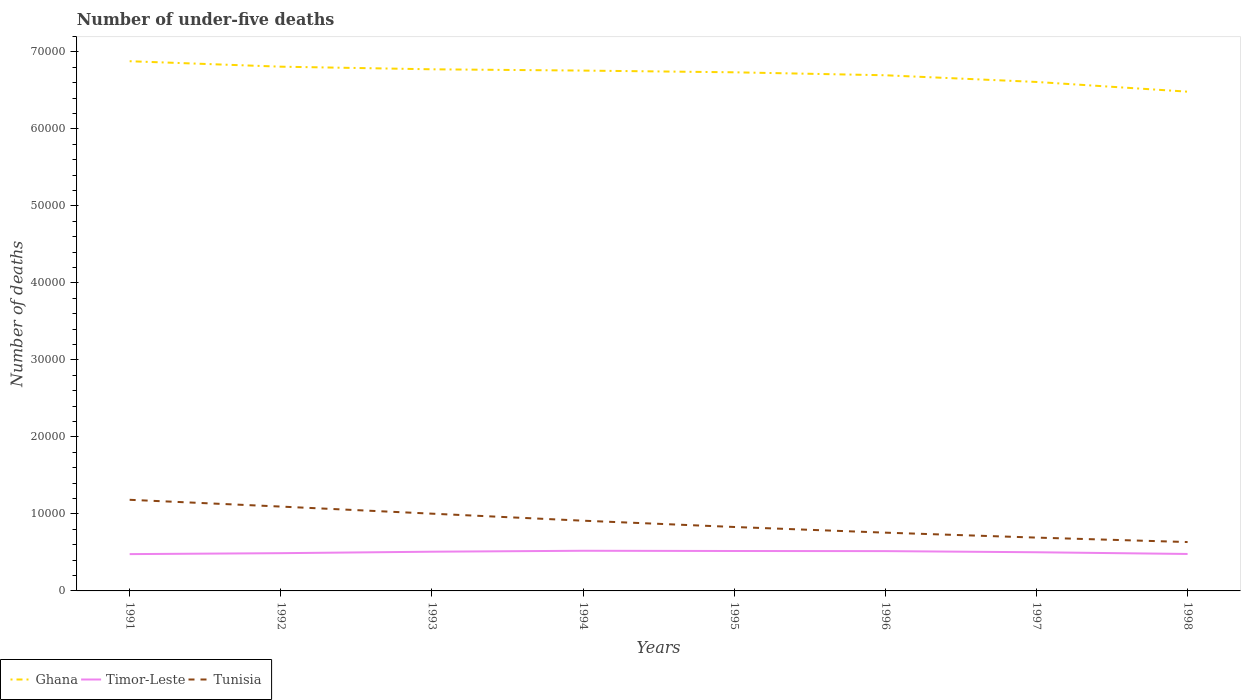How many different coloured lines are there?
Give a very brief answer. 3. Across all years, what is the maximum number of under-five deaths in Timor-Leste?
Your answer should be compact. 4782. What is the total number of under-five deaths in Ghana in the graph?
Give a very brief answer. 1825. What is the difference between the highest and the second highest number of under-five deaths in Ghana?
Your answer should be compact. 3954. What is the difference between the highest and the lowest number of under-five deaths in Ghana?
Offer a very short reply. 5. Is the number of under-five deaths in Ghana strictly greater than the number of under-five deaths in Tunisia over the years?
Your answer should be compact. No. How many lines are there?
Your answer should be very brief. 3. How many years are there in the graph?
Provide a succinct answer. 8. How many legend labels are there?
Your answer should be very brief. 3. How are the legend labels stacked?
Give a very brief answer. Horizontal. What is the title of the graph?
Make the answer very short. Number of under-five deaths. What is the label or title of the X-axis?
Your answer should be compact. Years. What is the label or title of the Y-axis?
Your answer should be very brief. Number of deaths. What is the Number of deaths in Ghana in 1991?
Offer a terse response. 6.88e+04. What is the Number of deaths of Timor-Leste in 1991?
Keep it short and to the point. 4782. What is the Number of deaths of Tunisia in 1991?
Your response must be concise. 1.18e+04. What is the Number of deaths of Ghana in 1992?
Give a very brief answer. 6.81e+04. What is the Number of deaths of Timor-Leste in 1992?
Provide a succinct answer. 4904. What is the Number of deaths of Tunisia in 1992?
Provide a succinct answer. 1.10e+04. What is the Number of deaths of Ghana in 1993?
Keep it short and to the point. 6.78e+04. What is the Number of deaths of Timor-Leste in 1993?
Make the answer very short. 5093. What is the Number of deaths of Tunisia in 1993?
Make the answer very short. 1.00e+04. What is the Number of deaths of Ghana in 1994?
Your answer should be compact. 6.76e+04. What is the Number of deaths of Timor-Leste in 1994?
Keep it short and to the point. 5215. What is the Number of deaths of Tunisia in 1994?
Offer a very short reply. 9122. What is the Number of deaths of Ghana in 1995?
Your answer should be very brief. 6.74e+04. What is the Number of deaths of Timor-Leste in 1995?
Offer a very short reply. 5186. What is the Number of deaths of Tunisia in 1995?
Your answer should be compact. 8305. What is the Number of deaths in Ghana in 1996?
Give a very brief answer. 6.70e+04. What is the Number of deaths of Timor-Leste in 1996?
Keep it short and to the point. 5170. What is the Number of deaths in Tunisia in 1996?
Ensure brevity in your answer.  7568. What is the Number of deaths in Ghana in 1997?
Keep it short and to the point. 6.61e+04. What is the Number of deaths in Timor-Leste in 1997?
Provide a short and direct response. 5023. What is the Number of deaths in Tunisia in 1997?
Offer a terse response. 6926. What is the Number of deaths of Ghana in 1998?
Keep it short and to the point. 6.48e+04. What is the Number of deaths in Timor-Leste in 1998?
Provide a succinct answer. 4799. What is the Number of deaths in Tunisia in 1998?
Ensure brevity in your answer.  6348. Across all years, what is the maximum Number of deaths of Ghana?
Give a very brief answer. 6.88e+04. Across all years, what is the maximum Number of deaths of Timor-Leste?
Your answer should be very brief. 5215. Across all years, what is the maximum Number of deaths in Tunisia?
Your answer should be compact. 1.18e+04. Across all years, what is the minimum Number of deaths of Ghana?
Keep it short and to the point. 6.48e+04. Across all years, what is the minimum Number of deaths in Timor-Leste?
Give a very brief answer. 4782. Across all years, what is the minimum Number of deaths in Tunisia?
Provide a succinct answer. 6348. What is the total Number of deaths of Ghana in the graph?
Offer a terse response. 5.38e+05. What is the total Number of deaths of Timor-Leste in the graph?
Provide a succinct answer. 4.02e+04. What is the total Number of deaths of Tunisia in the graph?
Your response must be concise. 7.11e+04. What is the difference between the Number of deaths in Ghana in 1991 and that in 1992?
Ensure brevity in your answer.  709. What is the difference between the Number of deaths in Timor-Leste in 1991 and that in 1992?
Ensure brevity in your answer.  -122. What is the difference between the Number of deaths in Tunisia in 1991 and that in 1992?
Your answer should be compact. 880. What is the difference between the Number of deaths in Ghana in 1991 and that in 1993?
Provide a succinct answer. 1049. What is the difference between the Number of deaths of Timor-Leste in 1991 and that in 1993?
Provide a short and direct response. -311. What is the difference between the Number of deaths of Tunisia in 1991 and that in 1993?
Provide a succinct answer. 1802. What is the difference between the Number of deaths in Ghana in 1991 and that in 1994?
Give a very brief answer. 1216. What is the difference between the Number of deaths in Timor-Leste in 1991 and that in 1994?
Your answer should be very brief. -433. What is the difference between the Number of deaths in Tunisia in 1991 and that in 1994?
Offer a very short reply. 2714. What is the difference between the Number of deaths in Ghana in 1991 and that in 1995?
Offer a terse response. 1439. What is the difference between the Number of deaths of Timor-Leste in 1991 and that in 1995?
Keep it short and to the point. -404. What is the difference between the Number of deaths in Tunisia in 1991 and that in 1995?
Provide a short and direct response. 3531. What is the difference between the Number of deaths in Ghana in 1991 and that in 1996?
Offer a very short reply. 1825. What is the difference between the Number of deaths of Timor-Leste in 1991 and that in 1996?
Offer a terse response. -388. What is the difference between the Number of deaths of Tunisia in 1991 and that in 1996?
Ensure brevity in your answer.  4268. What is the difference between the Number of deaths in Ghana in 1991 and that in 1997?
Your answer should be very brief. 2693. What is the difference between the Number of deaths of Timor-Leste in 1991 and that in 1997?
Your answer should be very brief. -241. What is the difference between the Number of deaths of Tunisia in 1991 and that in 1997?
Your response must be concise. 4910. What is the difference between the Number of deaths in Ghana in 1991 and that in 1998?
Keep it short and to the point. 3954. What is the difference between the Number of deaths in Tunisia in 1991 and that in 1998?
Provide a short and direct response. 5488. What is the difference between the Number of deaths of Ghana in 1992 and that in 1993?
Your answer should be very brief. 340. What is the difference between the Number of deaths in Timor-Leste in 1992 and that in 1993?
Your response must be concise. -189. What is the difference between the Number of deaths in Tunisia in 1992 and that in 1993?
Your answer should be compact. 922. What is the difference between the Number of deaths in Ghana in 1992 and that in 1994?
Keep it short and to the point. 507. What is the difference between the Number of deaths of Timor-Leste in 1992 and that in 1994?
Provide a short and direct response. -311. What is the difference between the Number of deaths in Tunisia in 1992 and that in 1994?
Provide a short and direct response. 1834. What is the difference between the Number of deaths of Ghana in 1992 and that in 1995?
Offer a terse response. 730. What is the difference between the Number of deaths of Timor-Leste in 1992 and that in 1995?
Provide a succinct answer. -282. What is the difference between the Number of deaths in Tunisia in 1992 and that in 1995?
Offer a terse response. 2651. What is the difference between the Number of deaths of Ghana in 1992 and that in 1996?
Your answer should be very brief. 1116. What is the difference between the Number of deaths of Timor-Leste in 1992 and that in 1996?
Your response must be concise. -266. What is the difference between the Number of deaths in Tunisia in 1992 and that in 1996?
Your response must be concise. 3388. What is the difference between the Number of deaths of Ghana in 1992 and that in 1997?
Your answer should be very brief. 1984. What is the difference between the Number of deaths of Timor-Leste in 1992 and that in 1997?
Provide a succinct answer. -119. What is the difference between the Number of deaths of Tunisia in 1992 and that in 1997?
Provide a succinct answer. 4030. What is the difference between the Number of deaths in Ghana in 1992 and that in 1998?
Your answer should be very brief. 3245. What is the difference between the Number of deaths of Timor-Leste in 1992 and that in 1998?
Offer a very short reply. 105. What is the difference between the Number of deaths of Tunisia in 1992 and that in 1998?
Your response must be concise. 4608. What is the difference between the Number of deaths of Ghana in 1993 and that in 1994?
Provide a succinct answer. 167. What is the difference between the Number of deaths of Timor-Leste in 1993 and that in 1994?
Your response must be concise. -122. What is the difference between the Number of deaths in Tunisia in 1993 and that in 1994?
Your answer should be very brief. 912. What is the difference between the Number of deaths in Ghana in 1993 and that in 1995?
Your response must be concise. 390. What is the difference between the Number of deaths of Timor-Leste in 1993 and that in 1995?
Keep it short and to the point. -93. What is the difference between the Number of deaths of Tunisia in 1993 and that in 1995?
Give a very brief answer. 1729. What is the difference between the Number of deaths of Ghana in 1993 and that in 1996?
Ensure brevity in your answer.  776. What is the difference between the Number of deaths of Timor-Leste in 1993 and that in 1996?
Keep it short and to the point. -77. What is the difference between the Number of deaths in Tunisia in 1993 and that in 1996?
Make the answer very short. 2466. What is the difference between the Number of deaths in Ghana in 1993 and that in 1997?
Provide a succinct answer. 1644. What is the difference between the Number of deaths of Timor-Leste in 1993 and that in 1997?
Provide a short and direct response. 70. What is the difference between the Number of deaths of Tunisia in 1993 and that in 1997?
Provide a short and direct response. 3108. What is the difference between the Number of deaths in Ghana in 1993 and that in 1998?
Your response must be concise. 2905. What is the difference between the Number of deaths in Timor-Leste in 1993 and that in 1998?
Offer a terse response. 294. What is the difference between the Number of deaths in Tunisia in 1993 and that in 1998?
Provide a succinct answer. 3686. What is the difference between the Number of deaths of Ghana in 1994 and that in 1995?
Your answer should be very brief. 223. What is the difference between the Number of deaths in Timor-Leste in 1994 and that in 1995?
Provide a short and direct response. 29. What is the difference between the Number of deaths in Tunisia in 1994 and that in 1995?
Your answer should be compact. 817. What is the difference between the Number of deaths in Ghana in 1994 and that in 1996?
Offer a terse response. 609. What is the difference between the Number of deaths of Timor-Leste in 1994 and that in 1996?
Ensure brevity in your answer.  45. What is the difference between the Number of deaths in Tunisia in 1994 and that in 1996?
Make the answer very short. 1554. What is the difference between the Number of deaths of Ghana in 1994 and that in 1997?
Your response must be concise. 1477. What is the difference between the Number of deaths of Timor-Leste in 1994 and that in 1997?
Your answer should be compact. 192. What is the difference between the Number of deaths in Tunisia in 1994 and that in 1997?
Ensure brevity in your answer.  2196. What is the difference between the Number of deaths of Ghana in 1994 and that in 1998?
Make the answer very short. 2738. What is the difference between the Number of deaths in Timor-Leste in 1994 and that in 1998?
Offer a terse response. 416. What is the difference between the Number of deaths in Tunisia in 1994 and that in 1998?
Your answer should be compact. 2774. What is the difference between the Number of deaths in Ghana in 1995 and that in 1996?
Provide a succinct answer. 386. What is the difference between the Number of deaths in Tunisia in 1995 and that in 1996?
Provide a succinct answer. 737. What is the difference between the Number of deaths of Ghana in 1995 and that in 1997?
Keep it short and to the point. 1254. What is the difference between the Number of deaths of Timor-Leste in 1995 and that in 1997?
Your answer should be compact. 163. What is the difference between the Number of deaths of Tunisia in 1995 and that in 1997?
Provide a short and direct response. 1379. What is the difference between the Number of deaths of Ghana in 1995 and that in 1998?
Make the answer very short. 2515. What is the difference between the Number of deaths of Timor-Leste in 1995 and that in 1998?
Ensure brevity in your answer.  387. What is the difference between the Number of deaths of Tunisia in 1995 and that in 1998?
Your response must be concise. 1957. What is the difference between the Number of deaths in Ghana in 1996 and that in 1997?
Keep it short and to the point. 868. What is the difference between the Number of deaths of Timor-Leste in 1996 and that in 1997?
Your response must be concise. 147. What is the difference between the Number of deaths in Tunisia in 1996 and that in 1997?
Offer a terse response. 642. What is the difference between the Number of deaths of Ghana in 1996 and that in 1998?
Offer a very short reply. 2129. What is the difference between the Number of deaths of Timor-Leste in 1996 and that in 1998?
Your answer should be compact. 371. What is the difference between the Number of deaths of Tunisia in 1996 and that in 1998?
Offer a very short reply. 1220. What is the difference between the Number of deaths in Ghana in 1997 and that in 1998?
Your answer should be compact. 1261. What is the difference between the Number of deaths in Timor-Leste in 1997 and that in 1998?
Your answer should be very brief. 224. What is the difference between the Number of deaths of Tunisia in 1997 and that in 1998?
Make the answer very short. 578. What is the difference between the Number of deaths in Ghana in 1991 and the Number of deaths in Timor-Leste in 1992?
Offer a very short reply. 6.39e+04. What is the difference between the Number of deaths in Ghana in 1991 and the Number of deaths in Tunisia in 1992?
Your response must be concise. 5.78e+04. What is the difference between the Number of deaths of Timor-Leste in 1991 and the Number of deaths of Tunisia in 1992?
Provide a short and direct response. -6174. What is the difference between the Number of deaths of Ghana in 1991 and the Number of deaths of Timor-Leste in 1993?
Keep it short and to the point. 6.37e+04. What is the difference between the Number of deaths of Ghana in 1991 and the Number of deaths of Tunisia in 1993?
Keep it short and to the point. 5.88e+04. What is the difference between the Number of deaths of Timor-Leste in 1991 and the Number of deaths of Tunisia in 1993?
Your answer should be compact. -5252. What is the difference between the Number of deaths in Ghana in 1991 and the Number of deaths in Timor-Leste in 1994?
Make the answer very short. 6.36e+04. What is the difference between the Number of deaths of Ghana in 1991 and the Number of deaths of Tunisia in 1994?
Offer a terse response. 5.97e+04. What is the difference between the Number of deaths of Timor-Leste in 1991 and the Number of deaths of Tunisia in 1994?
Give a very brief answer. -4340. What is the difference between the Number of deaths of Ghana in 1991 and the Number of deaths of Timor-Leste in 1995?
Offer a very short reply. 6.36e+04. What is the difference between the Number of deaths of Ghana in 1991 and the Number of deaths of Tunisia in 1995?
Your answer should be compact. 6.05e+04. What is the difference between the Number of deaths in Timor-Leste in 1991 and the Number of deaths in Tunisia in 1995?
Make the answer very short. -3523. What is the difference between the Number of deaths in Ghana in 1991 and the Number of deaths in Timor-Leste in 1996?
Keep it short and to the point. 6.36e+04. What is the difference between the Number of deaths in Ghana in 1991 and the Number of deaths in Tunisia in 1996?
Make the answer very short. 6.12e+04. What is the difference between the Number of deaths of Timor-Leste in 1991 and the Number of deaths of Tunisia in 1996?
Provide a succinct answer. -2786. What is the difference between the Number of deaths in Ghana in 1991 and the Number of deaths in Timor-Leste in 1997?
Offer a terse response. 6.38e+04. What is the difference between the Number of deaths of Ghana in 1991 and the Number of deaths of Tunisia in 1997?
Keep it short and to the point. 6.19e+04. What is the difference between the Number of deaths of Timor-Leste in 1991 and the Number of deaths of Tunisia in 1997?
Make the answer very short. -2144. What is the difference between the Number of deaths in Ghana in 1991 and the Number of deaths in Timor-Leste in 1998?
Your answer should be compact. 6.40e+04. What is the difference between the Number of deaths of Ghana in 1991 and the Number of deaths of Tunisia in 1998?
Your answer should be compact. 6.25e+04. What is the difference between the Number of deaths in Timor-Leste in 1991 and the Number of deaths in Tunisia in 1998?
Offer a terse response. -1566. What is the difference between the Number of deaths in Ghana in 1992 and the Number of deaths in Timor-Leste in 1993?
Provide a succinct answer. 6.30e+04. What is the difference between the Number of deaths of Ghana in 1992 and the Number of deaths of Tunisia in 1993?
Provide a short and direct response. 5.81e+04. What is the difference between the Number of deaths of Timor-Leste in 1992 and the Number of deaths of Tunisia in 1993?
Your response must be concise. -5130. What is the difference between the Number of deaths of Ghana in 1992 and the Number of deaths of Timor-Leste in 1994?
Offer a very short reply. 6.29e+04. What is the difference between the Number of deaths of Ghana in 1992 and the Number of deaths of Tunisia in 1994?
Your answer should be compact. 5.90e+04. What is the difference between the Number of deaths of Timor-Leste in 1992 and the Number of deaths of Tunisia in 1994?
Offer a terse response. -4218. What is the difference between the Number of deaths in Ghana in 1992 and the Number of deaths in Timor-Leste in 1995?
Keep it short and to the point. 6.29e+04. What is the difference between the Number of deaths in Ghana in 1992 and the Number of deaths in Tunisia in 1995?
Offer a terse response. 5.98e+04. What is the difference between the Number of deaths in Timor-Leste in 1992 and the Number of deaths in Tunisia in 1995?
Your answer should be compact. -3401. What is the difference between the Number of deaths of Ghana in 1992 and the Number of deaths of Timor-Leste in 1996?
Your answer should be compact. 6.29e+04. What is the difference between the Number of deaths in Ghana in 1992 and the Number of deaths in Tunisia in 1996?
Ensure brevity in your answer.  6.05e+04. What is the difference between the Number of deaths of Timor-Leste in 1992 and the Number of deaths of Tunisia in 1996?
Your answer should be compact. -2664. What is the difference between the Number of deaths in Ghana in 1992 and the Number of deaths in Timor-Leste in 1997?
Give a very brief answer. 6.31e+04. What is the difference between the Number of deaths of Ghana in 1992 and the Number of deaths of Tunisia in 1997?
Offer a terse response. 6.12e+04. What is the difference between the Number of deaths of Timor-Leste in 1992 and the Number of deaths of Tunisia in 1997?
Provide a short and direct response. -2022. What is the difference between the Number of deaths of Ghana in 1992 and the Number of deaths of Timor-Leste in 1998?
Provide a short and direct response. 6.33e+04. What is the difference between the Number of deaths in Ghana in 1992 and the Number of deaths in Tunisia in 1998?
Your response must be concise. 6.17e+04. What is the difference between the Number of deaths in Timor-Leste in 1992 and the Number of deaths in Tunisia in 1998?
Keep it short and to the point. -1444. What is the difference between the Number of deaths in Ghana in 1993 and the Number of deaths in Timor-Leste in 1994?
Provide a short and direct response. 6.25e+04. What is the difference between the Number of deaths in Ghana in 1993 and the Number of deaths in Tunisia in 1994?
Offer a terse response. 5.86e+04. What is the difference between the Number of deaths of Timor-Leste in 1993 and the Number of deaths of Tunisia in 1994?
Your answer should be compact. -4029. What is the difference between the Number of deaths of Ghana in 1993 and the Number of deaths of Timor-Leste in 1995?
Your answer should be very brief. 6.26e+04. What is the difference between the Number of deaths of Ghana in 1993 and the Number of deaths of Tunisia in 1995?
Your answer should be very brief. 5.94e+04. What is the difference between the Number of deaths in Timor-Leste in 1993 and the Number of deaths in Tunisia in 1995?
Provide a succinct answer. -3212. What is the difference between the Number of deaths in Ghana in 1993 and the Number of deaths in Timor-Leste in 1996?
Provide a short and direct response. 6.26e+04. What is the difference between the Number of deaths of Ghana in 1993 and the Number of deaths of Tunisia in 1996?
Offer a terse response. 6.02e+04. What is the difference between the Number of deaths in Timor-Leste in 1993 and the Number of deaths in Tunisia in 1996?
Offer a terse response. -2475. What is the difference between the Number of deaths of Ghana in 1993 and the Number of deaths of Timor-Leste in 1997?
Your response must be concise. 6.27e+04. What is the difference between the Number of deaths in Ghana in 1993 and the Number of deaths in Tunisia in 1997?
Your answer should be very brief. 6.08e+04. What is the difference between the Number of deaths in Timor-Leste in 1993 and the Number of deaths in Tunisia in 1997?
Ensure brevity in your answer.  -1833. What is the difference between the Number of deaths of Ghana in 1993 and the Number of deaths of Timor-Leste in 1998?
Offer a very short reply. 6.30e+04. What is the difference between the Number of deaths of Ghana in 1993 and the Number of deaths of Tunisia in 1998?
Your response must be concise. 6.14e+04. What is the difference between the Number of deaths in Timor-Leste in 1993 and the Number of deaths in Tunisia in 1998?
Provide a succinct answer. -1255. What is the difference between the Number of deaths of Ghana in 1994 and the Number of deaths of Timor-Leste in 1995?
Give a very brief answer. 6.24e+04. What is the difference between the Number of deaths in Ghana in 1994 and the Number of deaths in Tunisia in 1995?
Provide a short and direct response. 5.93e+04. What is the difference between the Number of deaths of Timor-Leste in 1994 and the Number of deaths of Tunisia in 1995?
Offer a very short reply. -3090. What is the difference between the Number of deaths in Ghana in 1994 and the Number of deaths in Timor-Leste in 1996?
Offer a very short reply. 6.24e+04. What is the difference between the Number of deaths in Ghana in 1994 and the Number of deaths in Tunisia in 1996?
Make the answer very short. 6.00e+04. What is the difference between the Number of deaths in Timor-Leste in 1994 and the Number of deaths in Tunisia in 1996?
Your response must be concise. -2353. What is the difference between the Number of deaths in Ghana in 1994 and the Number of deaths in Timor-Leste in 1997?
Give a very brief answer. 6.26e+04. What is the difference between the Number of deaths of Ghana in 1994 and the Number of deaths of Tunisia in 1997?
Offer a terse response. 6.07e+04. What is the difference between the Number of deaths of Timor-Leste in 1994 and the Number of deaths of Tunisia in 1997?
Provide a short and direct response. -1711. What is the difference between the Number of deaths of Ghana in 1994 and the Number of deaths of Timor-Leste in 1998?
Provide a succinct answer. 6.28e+04. What is the difference between the Number of deaths in Ghana in 1994 and the Number of deaths in Tunisia in 1998?
Provide a succinct answer. 6.12e+04. What is the difference between the Number of deaths in Timor-Leste in 1994 and the Number of deaths in Tunisia in 1998?
Provide a short and direct response. -1133. What is the difference between the Number of deaths in Ghana in 1995 and the Number of deaths in Timor-Leste in 1996?
Give a very brief answer. 6.22e+04. What is the difference between the Number of deaths of Ghana in 1995 and the Number of deaths of Tunisia in 1996?
Keep it short and to the point. 5.98e+04. What is the difference between the Number of deaths of Timor-Leste in 1995 and the Number of deaths of Tunisia in 1996?
Offer a terse response. -2382. What is the difference between the Number of deaths in Ghana in 1995 and the Number of deaths in Timor-Leste in 1997?
Offer a terse response. 6.23e+04. What is the difference between the Number of deaths in Ghana in 1995 and the Number of deaths in Tunisia in 1997?
Keep it short and to the point. 6.04e+04. What is the difference between the Number of deaths of Timor-Leste in 1995 and the Number of deaths of Tunisia in 1997?
Offer a terse response. -1740. What is the difference between the Number of deaths in Ghana in 1995 and the Number of deaths in Timor-Leste in 1998?
Make the answer very short. 6.26e+04. What is the difference between the Number of deaths of Ghana in 1995 and the Number of deaths of Tunisia in 1998?
Give a very brief answer. 6.10e+04. What is the difference between the Number of deaths in Timor-Leste in 1995 and the Number of deaths in Tunisia in 1998?
Provide a succinct answer. -1162. What is the difference between the Number of deaths in Ghana in 1996 and the Number of deaths in Timor-Leste in 1997?
Offer a very short reply. 6.20e+04. What is the difference between the Number of deaths in Ghana in 1996 and the Number of deaths in Tunisia in 1997?
Give a very brief answer. 6.00e+04. What is the difference between the Number of deaths in Timor-Leste in 1996 and the Number of deaths in Tunisia in 1997?
Ensure brevity in your answer.  -1756. What is the difference between the Number of deaths of Ghana in 1996 and the Number of deaths of Timor-Leste in 1998?
Ensure brevity in your answer.  6.22e+04. What is the difference between the Number of deaths of Ghana in 1996 and the Number of deaths of Tunisia in 1998?
Keep it short and to the point. 6.06e+04. What is the difference between the Number of deaths in Timor-Leste in 1996 and the Number of deaths in Tunisia in 1998?
Provide a succinct answer. -1178. What is the difference between the Number of deaths in Ghana in 1997 and the Number of deaths in Timor-Leste in 1998?
Your answer should be very brief. 6.13e+04. What is the difference between the Number of deaths of Ghana in 1997 and the Number of deaths of Tunisia in 1998?
Ensure brevity in your answer.  5.98e+04. What is the difference between the Number of deaths in Timor-Leste in 1997 and the Number of deaths in Tunisia in 1998?
Ensure brevity in your answer.  -1325. What is the average Number of deaths in Ghana per year?
Provide a succinct answer. 6.72e+04. What is the average Number of deaths of Timor-Leste per year?
Your answer should be compact. 5021.5. What is the average Number of deaths in Tunisia per year?
Your response must be concise. 8886.88. In the year 1991, what is the difference between the Number of deaths in Ghana and Number of deaths in Timor-Leste?
Offer a very short reply. 6.40e+04. In the year 1991, what is the difference between the Number of deaths in Ghana and Number of deaths in Tunisia?
Your response must be concise. 5.70e+04. In the year 1991, what is the difference between the Number of deaths in Timor-Leste and Number of deaths in Tunisia?
Offer a terse response. -7054. In the year 1992, what is the difference between the Number of deaths in Ghana and Number of deaths in Timor-Leste?
Offer a very short reply. 6.32e+04. In the year 1992, what is the difference between the Number of deaths of Ghana and Number of deaths of Tunisia?
Keep it short and to the point. 5.71e+04. In the year 1992, what is the difference between the Number of deaths of Timor-Leste and Number of deaths of Tunisia?
Provide a succinct answer. -6052. In the year 1993, what is the difference between the Number of deaths of Ghana and Number of deaths of Timor-Leste?
Make the answer very short. 6.27e+04. In the year 1993, what is the difference between the Number of deaths in Ghana and Number of deaths in Tunisia?
Keep it short and to the point. 5.77e+04. In the year 1993, what is the difference between the Number of deaths in Timor-Leste and Number of deaths in Tunisia?
Provide a succinct answer. -4941. In the year 1994, what is the difference between the Number of deaths of Ghana and Number of deaths of Timor-Leste?
Give a very brief answer. 6.24e+04. In the year 1994, what is the difference between the Number of deaths of Ghana and Number of deaths of Tunisia?
Give a very brief answer. 5.85e+04. In the year 1994, what is the difference between the Number of deaths in Timor-Leste and Number of deaths in Tunisia?
Ensure brevity in your answer.  -3907. In the year 1995, what is the difference between the Number of deaths in Ghana and Number of deaths in Timor-Leste?
Give a very brief answer. 6.22e+04. In the year 1995, what is the difference between the Number of deaths of Ghana and Number of deaths of Tunisia?
Your answer should be compact. 5.91e+04. In the year 1995, what is the difference between the Number of deaths in Timor-Leste and Number of deaths in Tunisia?
Your answer should be compact. -3119. In the year 1996, what is the difference between the Number of deaths in Ghana and Number of deaths in Timor-Leste?
Give a very brief answer. 6.18e+04. In the year 1996, what is the difference between the Number of deaths in Ghana and Number of deaths in Tunisia?
Give a very brief answer. 5.94e+04. In the year 1996, what is the difference between the Number of deaths in Timor-Leste and Number of deaths in Tunisia?
Keep it short and to the point. -2398. In the year 1997, what is the difference between the Number of deaths of Ghana and Number of deaths of Timor-Leste?
Ensure brevity in your answer.  6.11e+04. In the year 1997, what is the difference between the Number of deaths in Ghana and Number of deaths in Tunisia?
Ensure brevity in your answer.  5.92e+04. In the year 1997, what is the difference between the Number of deaths in Timor-Leste and Number of deaths in Tunisia?
Make the answer very short. -1903. In the year 1998, what is the difference between the Number of deaths of Ghana and Number of deaths of Timor-Leste?
Your answer should be compact. 6.00e+04. In the year 1998, what is the difference between the Number of deaths in Ghana and Number of deaths in Tunisia?
Offer a terse response. 5.85e+04. In the year 1998, what is the difference between the Number of deaths in Timor-Leste and Number of deaths in Tunisia?
Offer a terse response. -1549. What is the ratio of the Number of deaths in Ghana in 1991 to that in 1992?
Provide a short and direct response. 1.01. What is the ratio of the Number of deaths of Timor-Leste in 1991 to that in 1992?
Ensure brevity in your answer.  0.98. What is the ratio of the Number of deaths of Tunisia in 1991 to that in 1992?
Give a very brief answer. 1.08. What is the ratio of the Number of deaths in Ghana in 1991 to that in 1993?
Provide a succinct answer. 1.02. What is the ratio of the Number of deaths of Timor-Leste in 1991 to that in 1993?
Ensure brevity in your answer.  0.94. What is the ratio of the Number of deaths of Tunisia in 1991 to that in 1993?
Your answer should be compact. 1.18. What is the ratio of the Number of deaths of Ghana in 1991 to that in 1994?
Ensure brevity in your answer.  1.02. What is the ratio of the Number of deaths of Timor-Leste in 1991 to that in 1994?
Make the answer very short. 0.92. What is the ratio of the Number of deaths in Tunisia in 1991 to that in 1994?
Your response must be concise. 1.3. What is the ratio of the Number of deaths in Ghana in 1991 to that in 1995?
Provide a succinct answer. 1.02. What is the ratio of the Number of deaths of Timor-Leste in 1991 to that in 1995?
Make the answer very short. 0.92. What is the ratio of the Number of deaths of Tunisia in 1991 to that in 1995?
Provide a succinct answer. 1.43. What is the ratio of the Number of deaths in Ghana in 1991 to that in 1996?
Offer a terse response. 1.03. What is the ratio of the Number of deaths in Timor-Leste in 1991 to that in 1996?
Ensure brevity in your answer.  0.93. What is the ratio of the Number of deaths of Tunisia in 1991 to that in 1996?
Keep it short and to the point. 1.56. What is the ratio of the Number of deaths in Ghana in 1991 to that in 1997?
Give a very brief answer. 1.04. What is the ratio of the Number of deaths in Timor-Leste in 1991 to that in 1997?
Provide a succinct answer. 0.95. What is the ratio of the Number of deaths of Tunisia in 1991 to that in 1997?
Give a very brief answer. 1.71. What is the ratio of the Number of deaths of Ghana in 1991 to that in 1998?
Give a very brief answer. 1.06. What is the ratio of the Number of deaths of Timor-Leste in 1991 to that in 1998?
Ensure brevity in your answer.  1. What is the ratio of the Number of deaths of Tunisia in 1991 to that in 1998?
Keep it short and to the point. 1.86. What is the ratio of the Number of deaths of Ghana in 1992 to that in 1993?
Offer a very short reply. 1. What is the ratio of the Number of deaths of Timor-Leste in 1992 to that in 1993?
Your answer should be very brief. 0.96. What is the ratio of the Number of deaths of Tunisia in 1992 to that in 1993?
Ensure brevity in your answer.  1.09. What is the ratio of the Number of deaths of Ghana in 1992 to that in 1994?
Your response must be concise. 1.01. What is the ratio of the Number of deaths of Timor-Leste in 1992 to that in 1994?
Ensure brevity in your answer.  0.94. What is the ratio of the Number of deaths of Tunisia in 1992 to that in 1994?
Your answer should be very brief. 1.2. What is the ratio of the Number of deaths of Ghana in 1992 to that in 1995?
Ensure brevity in your answer.  1.01. What is the ratio of the Number of deaths in Timor-Leste in 1992 to that in 1995?
Ensure brevity in your answer.  0.95. What is the ratio of the Number of deaths of Tunisia in 1992 to that in 1995?
Your answer should be very brief. 1.32. What is the ratio of the Number of deaths of Ghana in 1992 to that in 1996?
Offer a very short reply. 1.02. What is the ratio of the Number of deaths in Timor-Leste in 1992 to that in 1996?
Offer a terse response. 0.95. What is the ratio of the Number of deaths in Tunisia in 1992 to that in 1996?
Keep it short and to the point. 1.45. What is the ratio of the Number of deaths in Ghana in 1992 to that in 1997?
Give a very brief answer. 1.03. What is the ratio of the Number of deaths in Timor-Leste in 1992 to that in 1997?
Your answer should be very brief. 0.98. What is the ratio of the Number of deaths of Tunisia in 1992 to that in 1997?
Your answer should be very brief. 1.58. What is the ratio of the Number of deaths of Timor-Leste in 1992 to that in 1998?
Make the answer very short. 1.02. What is the ratio of the Number of deaths of Tunisia in 1992 to that in 1998?
Keep it short and to the point. 1.73. What is the ratio of the Number of deaths of Timor-Leste in 1993 to that in 1994?
Offer a terse response. 0.98. What is the ratio of the Number of deaths of Tunisia in 1993 to that in 1994?
Your response must be concise. 1.1. What is the ratio of the Number of deaths of Timor-Leste in 1993 to that in 1995?
Provide a succinct answer. 0.98. What is the ratio of the Number of deaths of Tunisia in 1993 to that in 1995?
Ensure brevity in your answer.  1.21. What is the ratio of the Number of deaths of Ghana in 1993 to that in 1996?
Ensure brevity in your answer.  1.01. What is the ratio of the Number of deaths of Timor-Leste in 1993 to that in 1996?
Keep it short and to the point. 0.99. What is the ratio of the Number of deaths of Tunisia in 1993 to that in 1996?
Keep it short and to the point. 1.33. What is the ratio of the Number of deaths in Ghana in 1993 to that in 1997?
Make the answer very short. 1.02. What is the ratio of the Number of deaths in Timor-Leste in 1993 to that in 1997?
Give a very brief answer. 1.01. What is the ratio of the Number of deaths in Tunisia in 1993 to that in 1997?
Ensure brevity in your answer.  1.45. What is the ratio of the Number of deaths of Ghana in 1993 to that in 1998?
Your answer should be very brief. 1.04. What is the ratio of the Number of deaths of Timor-Leste in 1993 to that in 1998?
Provide a short and direct response. 1.06. What is the ratio of the Number of deaths of Tunisia in 1993 to that in 1998?
Give a very brief answer. 1.58. What is the ratio of the Number of deaths in Ghana in 1994 to that in 1995?
Ensure brevity in your answer.  1. What is the ratio of the Number of deaths in Timor-Leste in 1994 to that in 1995?
Keep it short and to the point. 1.01. What is the ratio of the Number of deaths of Tunisia in 1994 to that in 1995?
Ensure brevity in your answer.  1.1. What is the ratio of the Number of deaths in Ghana in 1994 to that in 1996?
Your answer should be compact. 1.01. What is the ratio of the Number of deaths of Timor-Leste in 1994 to that in 1996?
Provide a succinct answer. 1.01. What is the ratio of the Number of deaths of Tunisia in 1994 to that in 1996?
Provide a succinct answer. 1.21. What is the ratio of the Number of deaths in Ghana in 1994 to that in 1997?
Give a very brief answer. 1.02. What is the ratio of the Number of deaths in Timor-Leste in 1994 to that in 1997?
Give a very brief answer. 1.04. What is the ratio of the Number of deaths of Tunisia in 1994 to that in 1997?
Your response must be concise. 1.32. What is the ratio of the Number of deaths in Ghana in 1994 to that in 1998?
Your response must be concise. 1.04. What is the ratio of the Number of deaths in Timor-Leste in 1994 to that in 1998?
Offer a very short reply. 1.09. What is the ratio of the Number of deaths of Tunisia in 1994 to that in 1998?
Offer a very short reply. 1.44. What is the ratio of the Number of deaths of Tunisia in 1995 to that in 1996?
Make the answer very short. 1.1. What is the ratio of the Number of deaths in Ghana in 1995 to that in 1997?
Ensure brevity in your answer.  1.02. What is the ratio of the Number of deaths in Timor-Leste in 1995 to that in 1997?
Provide a short and direct response. 1.03. What is the ratio of the Number of deaths of Tunisia in 1995 to that in 1997?
Offer a terse response. 1.2. What is the ratio of the Number of deaths of Ghana in 1995 to that in 1998?
Provide a short and direct response. 1.04. What is the ratio of the Number of deaths of Timor-Leste in 1995 to that in 1998?
Keep it short and to the point. 1.08. What is the ratio of the Number of deaths in Tunisia in 1995 to that in 1998?
Provide a short and direct response. 1.31. What is the ratio of the Number of deaths in Ghana in 1996 to that in 1997?
Provide a succinct answer. 1.01. What is the ratio of the Number of deaths in Timor-Leste in 1996 to that in 1997?
Your answer should be compact. 1.03. What is the ratio of the Number of deaths of Tunisia in 1996 to that in 1997?
Give a very brief answer. 1.09. What is the ratio of the Number of deaths of Ghana in 1996 to that in 1998?
Your answer should be very brief. 1.03. What is the ratio of the Number of deaths of Timor-Leste in 1996 to that in 1998?
Your answer should be very brief. 1.08. What is the ratio of the Number of deaths of Tunisia in 1996 to that in 1998?
Offer a terse response. 1.19. What is the ratio of the Number of deaths in Ghana in 1997 to that in 1998?
Keep it short and to the point. 1.02. What is the ratio of the Number of deaths of Timor-Leste in 1997 to that in 1998?
Provide a short and direct response. 1.05. What is the ratio of the Number of deaths of Tunisia in 1997 to that in 1998?
Offer a terse response. 1.09. What is the difference between the highest and the second highest Number of deaths in Ghana?
Your response must be concise. 709. What is the difference between the highest and the second highest Number of deaths in Tunisia?
Provide a succinct answer. 880. What is the difference between the highest and the lowest Number of deaths of Ghana?
Your answer should be very brief. 3954. What is the difference between the highest and the lowest Number of deaths in Timor-Leste?
Your response must be concise. 433. What is the difference between the highest and the lowest Number of deaths in Tunisia?
Ensure brevity in your answer.  5488. 